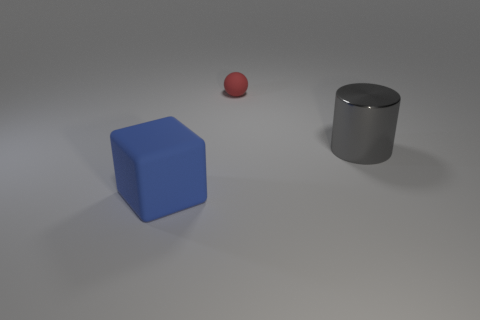What can you tell me about the lighting in this scene? The scene is softly lit from above, casting gentle shadows beneath the objects and indicating a diffused light source, possibly to simulate an overcast day or indoor lighting. 